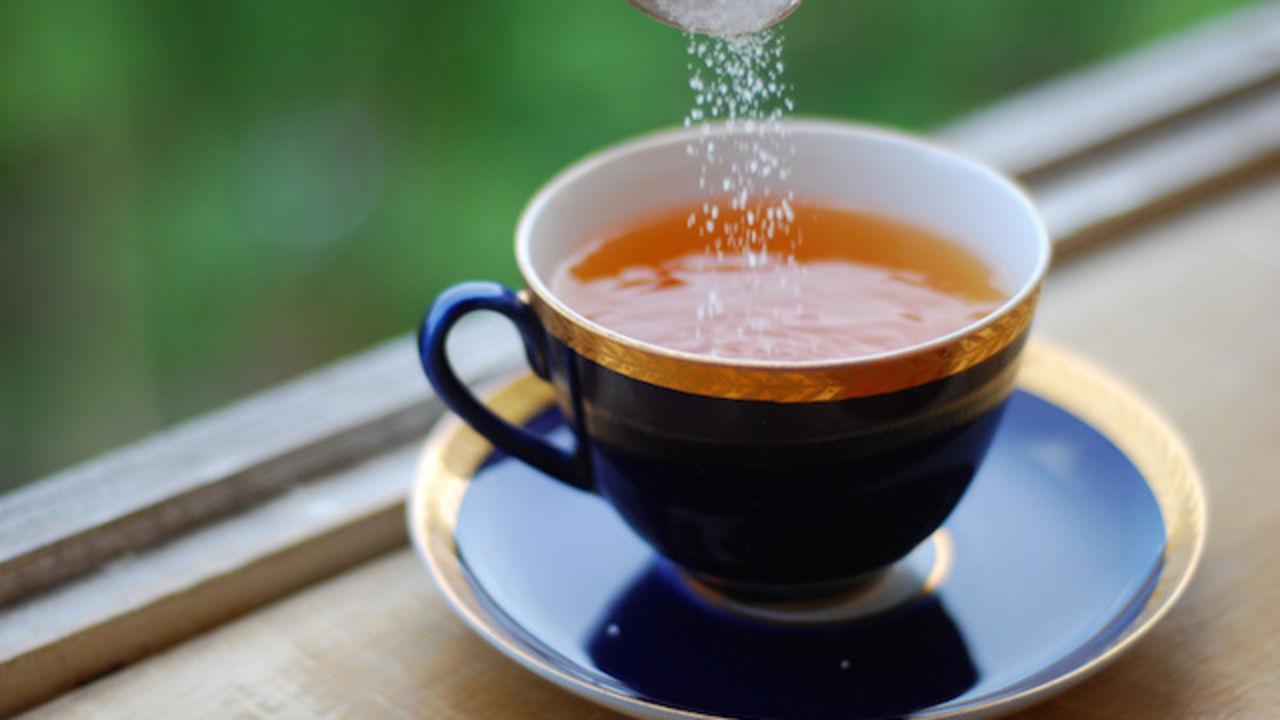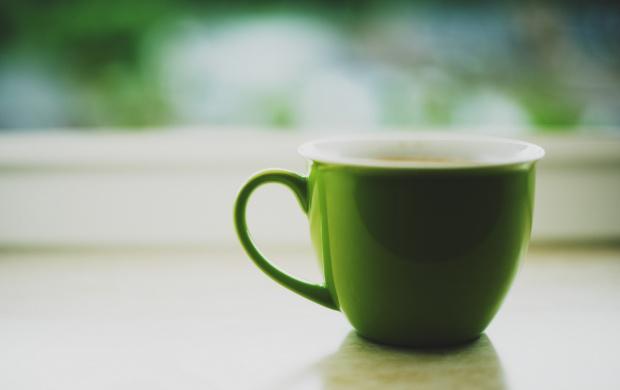The first image is the image on the left, the second image is the image on the right. Examine the images to the left and right. Is the description "Brown liquid sits in a single mug in the cup on the left." accurate? Answer yes or no. Yes. The first image is the image on the left, the second image is the image on the right. Examine the images to the left and right. Is the description "There are no less than two coffee mugs with handles" accurate? Answer yes or no. Yes. 